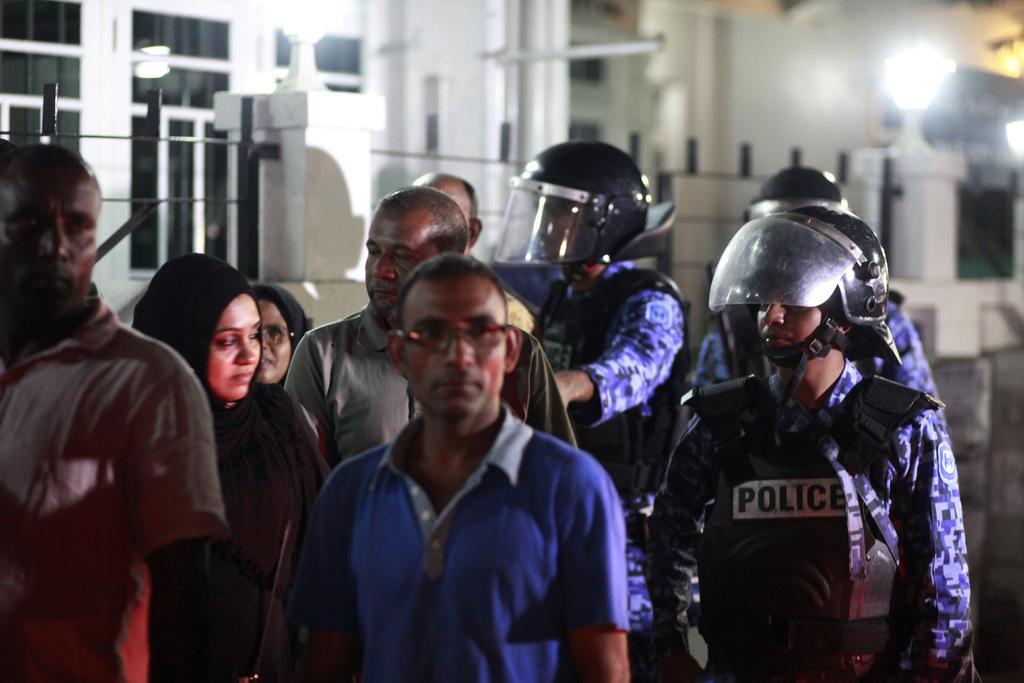Can you describe this image briefly? On the left side, we see two women and four men are standing. Beside them, we see three men in the uniform who are wearing the life jackets and the black helmets are standing. In the background, we see the railing, lights and the building in white color. This picture is blurred in the background. 